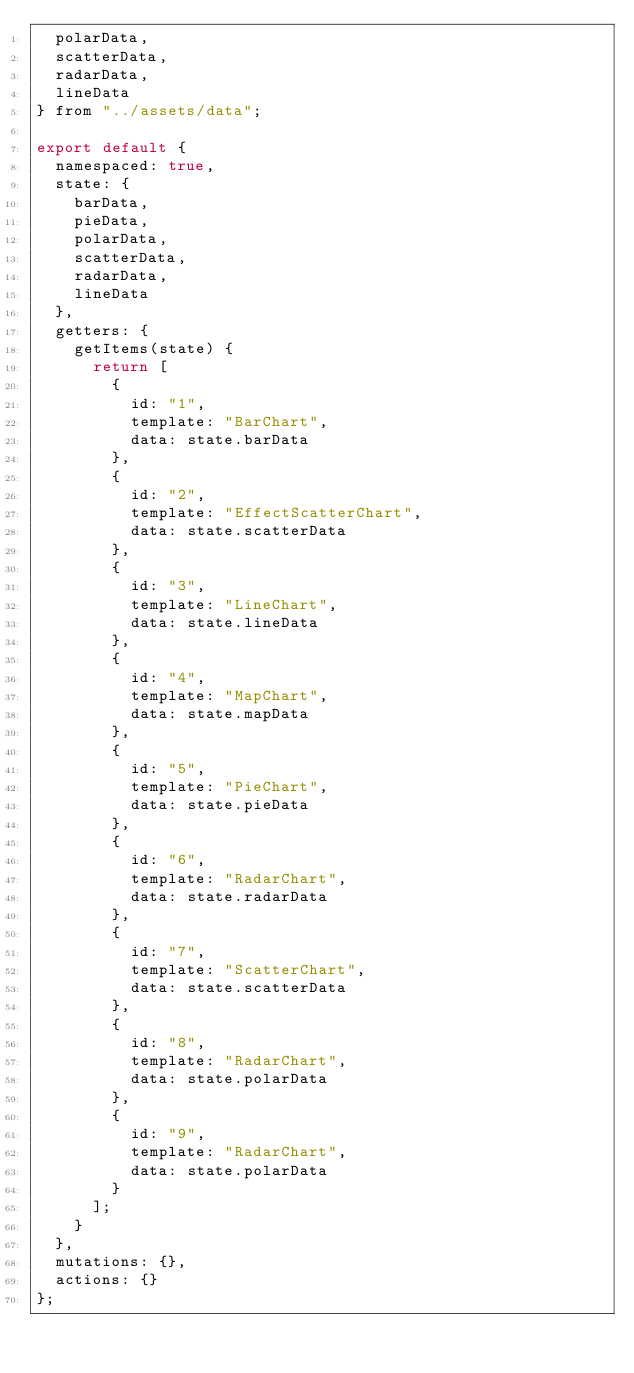<code> <loc_0><loc_0><loc_500><loc_500><_JavaScript_>  polarData,
  scatterData,
  radarData,
  lineData
} from "../assets/data";

export default {
  namespaced: true,
  state: {
    barData,
    pieData,
    polarData,
    scatterData,
    radarData,
    lineData
  },
  getters: {
    getItems(state) {
      return [
        {
          id: "1",
          template: "BarChart",
          data: state.barData
        },
        {
          id: "2",
          template: "EffectScatterChart",
          data: state.scatterData
        },
        {
          id: "3",
          template: "LineChart",
          data: state.lineData
        },
        {
          id: "4",
          template: "MapChart",
          data: state.mapData
        },
        {
          id: "5",
          template: "PieChart",
          data: state.pieData
        },
        {
          id: "6",
          template: "RadarChart",
          data: state.radarData
        },
        {
          id: "7",
          template: "ScatterChart",
          data: state.scatterData
        },
        {
          id: "8",
          template: "RadarChart",
          data: state.polarData
        },
        {
          id: "9",
          template: "RadarChart",
          data: state.polarData
        }
      ];
    }
  },
  mutations: {},
  actions: {}
};
</code> 